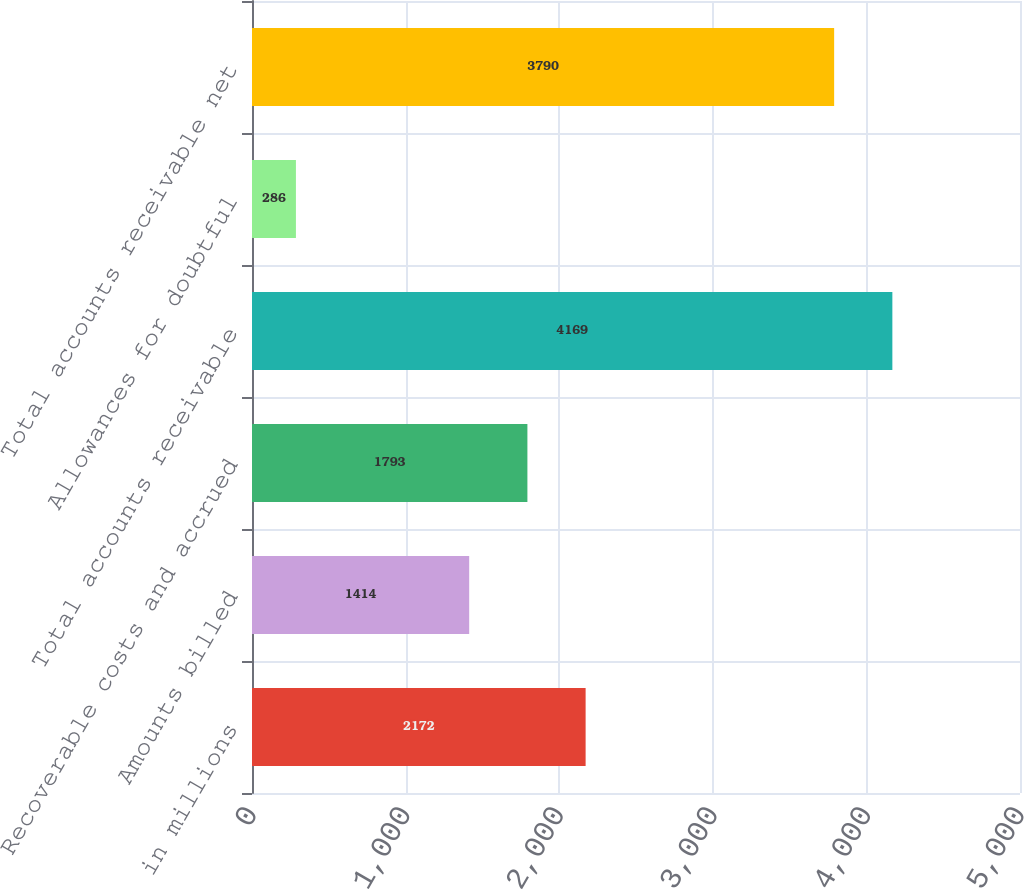Convert chart. <chart><loc_0><loc_0><loc_500><loc_500><bar_chart><fcel>in millions<fcel>Amounts billed<fcel>Recoverable costs and accrued<fcel>Total accounts receivable<fcel>Allowances for doubtful<fcel>Total accounts receivable net<nl><fcel>2172<fcel>1414<fcel>1793<fcel>4169<fcel>286<fcel>3790<nl></chart> 